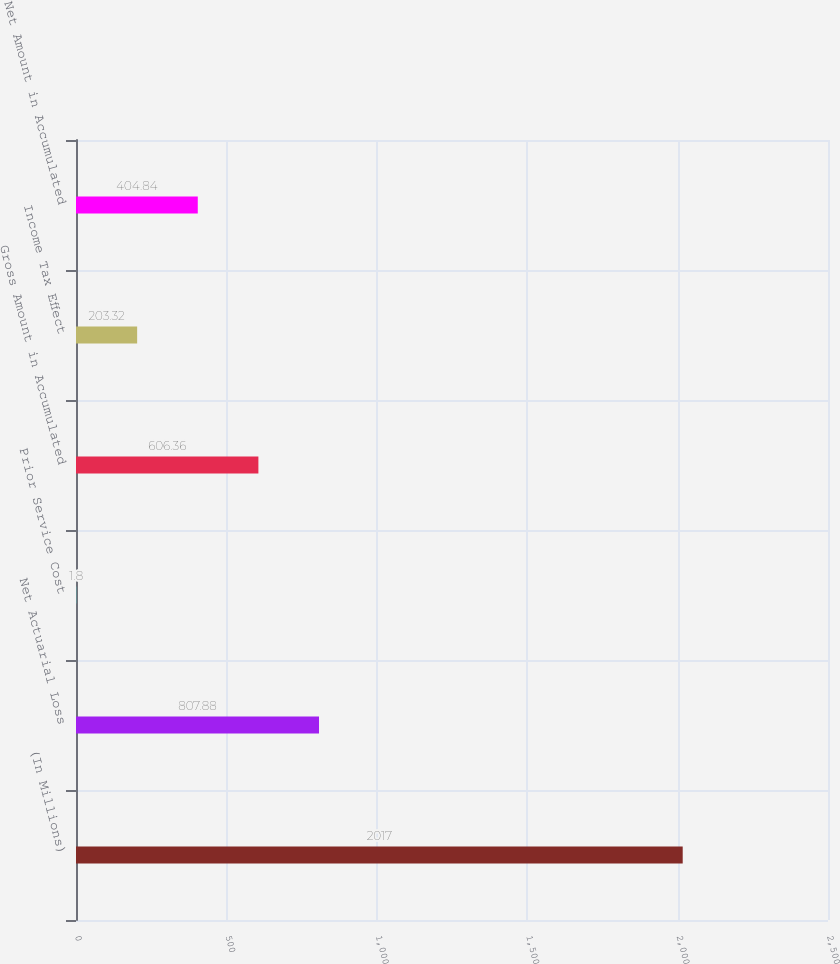<chart> <loc_0><loc_0><loc_500><loc_500><bar_chart><fcel>(In Millions)<fcel>Net Actuarial Loss<fcel>Prior Service Cost<fcel>Gross Amount in Accumulated<fcel>Income Tax Effect<fcel>Net Amount in Accumulated<nl><fcel>2017<fcel>807.88<fcel>1.8<fcel>606.36<fcel>203.32<fcel>404.84<nl></chart> 